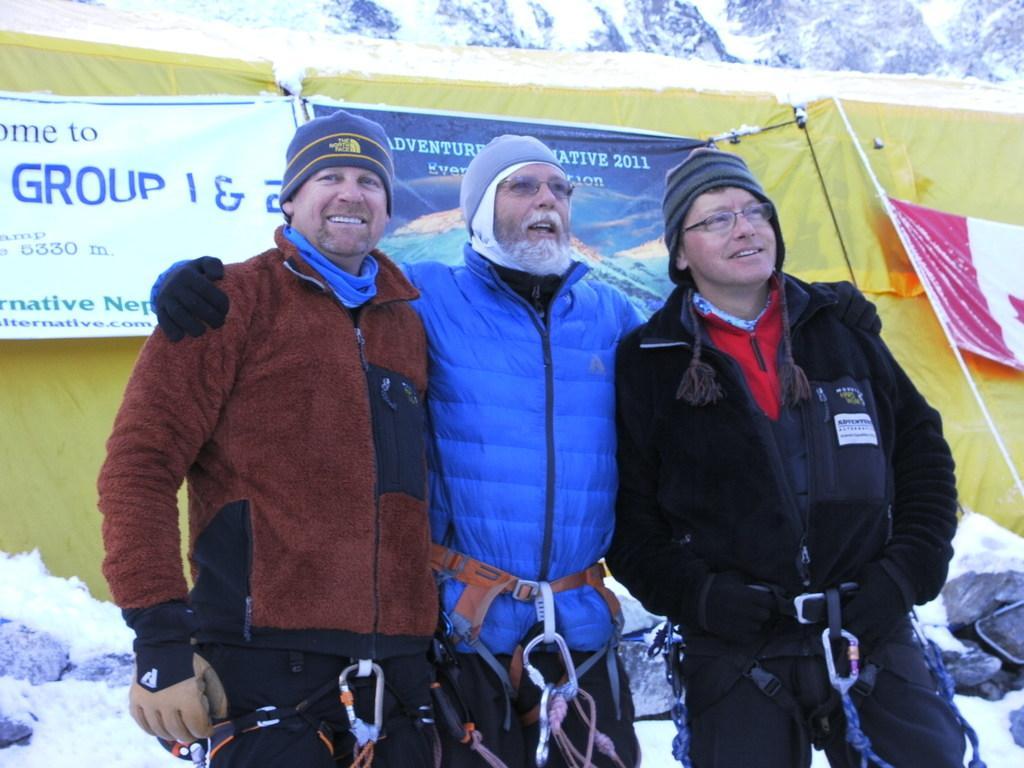Please provide a concise description of this image. In the image we can see three men standing, wearing clothes, gloves, cap and two of them are wearing spectacles and they are smiling. Behind them, we can see tent, posters and text on it. Here we can see the rope and snow. 